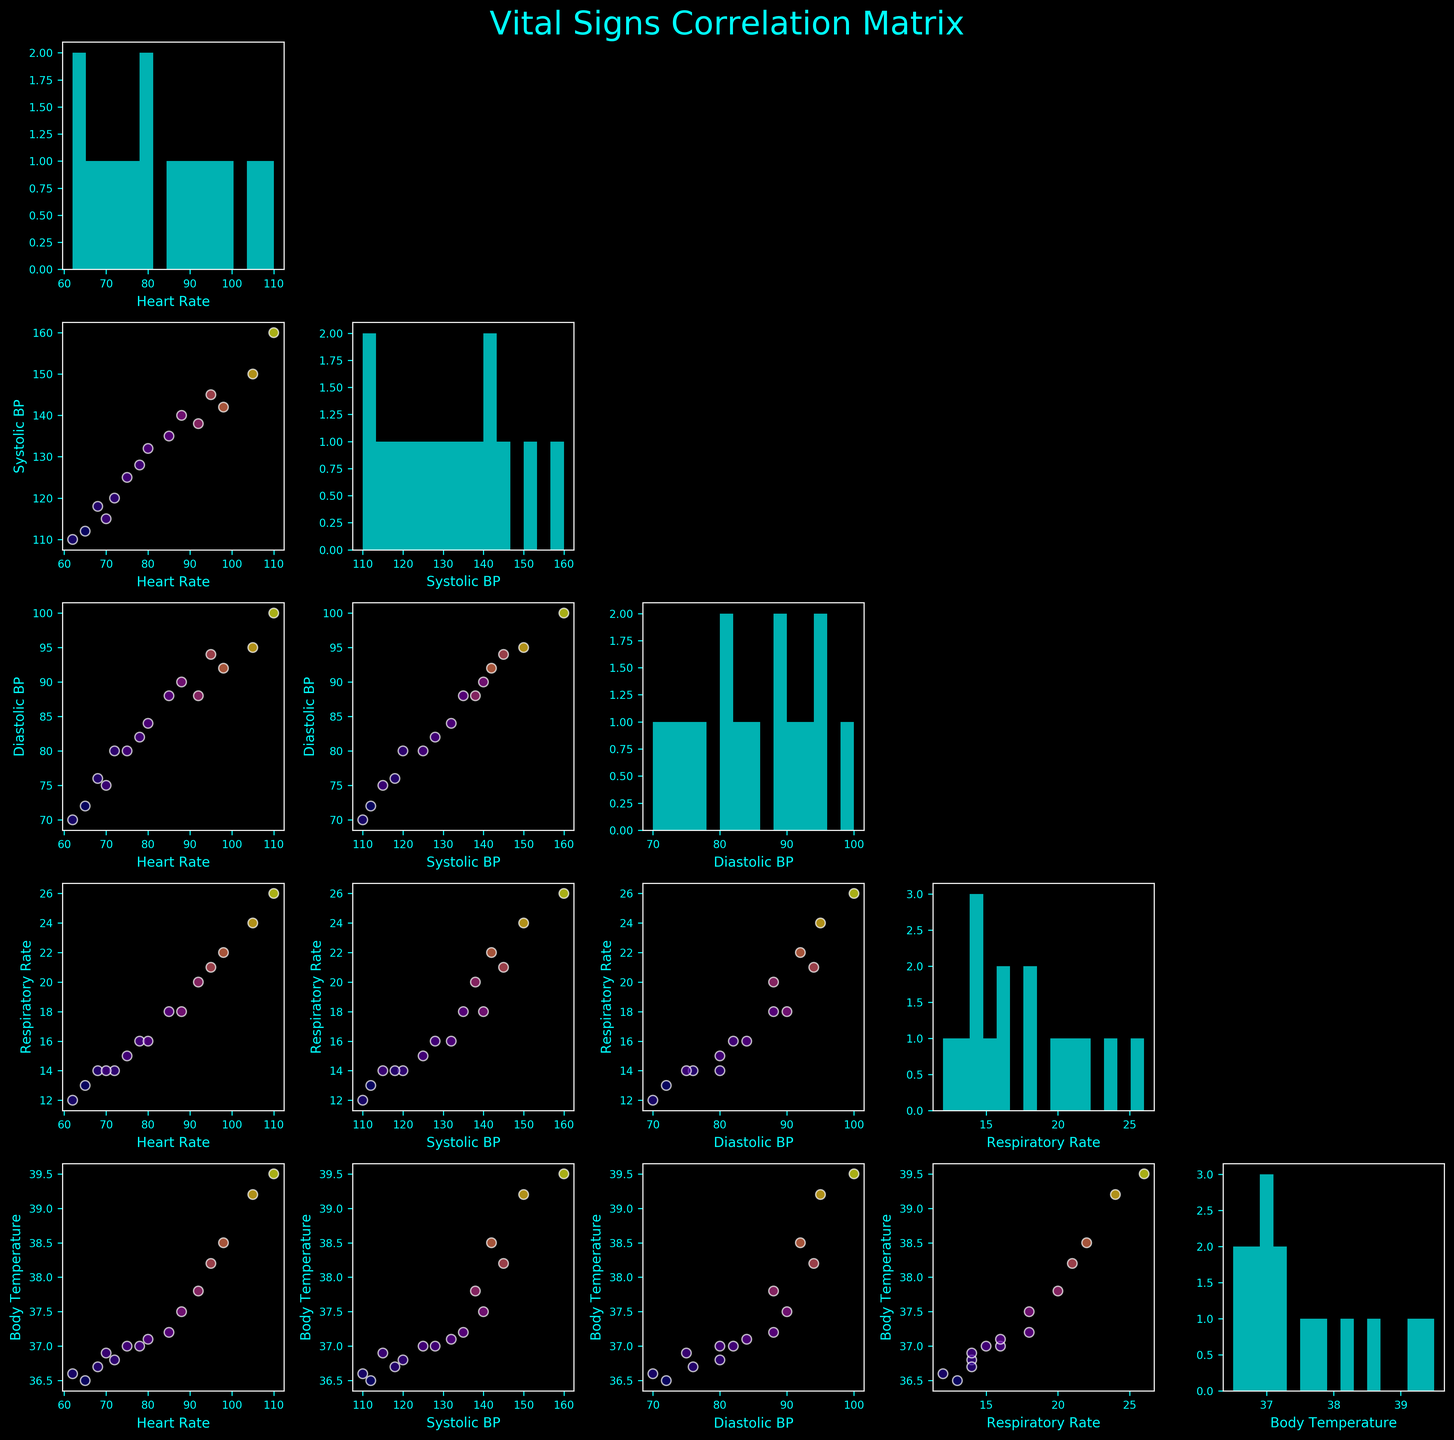What is the title of the figure? The title is written on the top of the figure. It is "Vital Signs Correlation Matrix".
Answer: Vital Signs Correlation Matrix How many variables are being analyzed in the scatterplot matrix? The number of variables can be counted by looking at the grid. There are five: Heart Rate, Systolic BP, Diastolic BP, Respiratory Rate, and Body Temperature.
Answer: Five Which variable has the widest range of values in the histogram plots along the diagonal? By observing the histograms on the diagonal, the variable with the widest range appears to be "Systolic BP".
Answer: Systolic BP Is there a visible correlation between Heart Rate and Body Temperature? Looking at the scatterplot between Heart Rate and Body Temperature, there is an upward trend indicating a positive correlation.
Answer: Yes Which scatterplot indicates the strongest positive correlation? To determine the strongest positive correlation, compare the scatterplots. The scatterplot between Systolic BP and Diastolic BP shows a strong positive trend.
Answer: Systolic BP vs Diastolic BP Are there any outliers visible in the scatterplot between Heart Rate and Respiratory Rate? In the scatterplot between Heart Rate and Respiratory Rate, one can see outliers as points that do not fit the general pattern. There appear to be some outliers at higher heart rates.
Answer: Yes Which variable seems most strongly associated with Body Temperature? Comparing the scatterplots against Body Temperature, Heart Rate shows the strongest associated pattern.
Answer: Heart Rate Do any scatterplots show a negative correlation? By examining all the scatterplots, no distinct negative correlation is noticeable. Most scatterplots either show positive correlations or no clear pattern.
Answer: No Which variable has data points with the highest Body Temperature in the scatterplots? By looking at the color intensity (representing Body Temperature) across scatterplots, higher temperatures are notably associated with increased Heart Rate values.
Answer: Heart Rate What is the trend noticed between Systolic BP and Respiratory Rate? In the scatterplot between Systolic BP and Respiratory Rate, there is a visible upward trend, indicating a positive correlation.
Answer: Positive correlation 